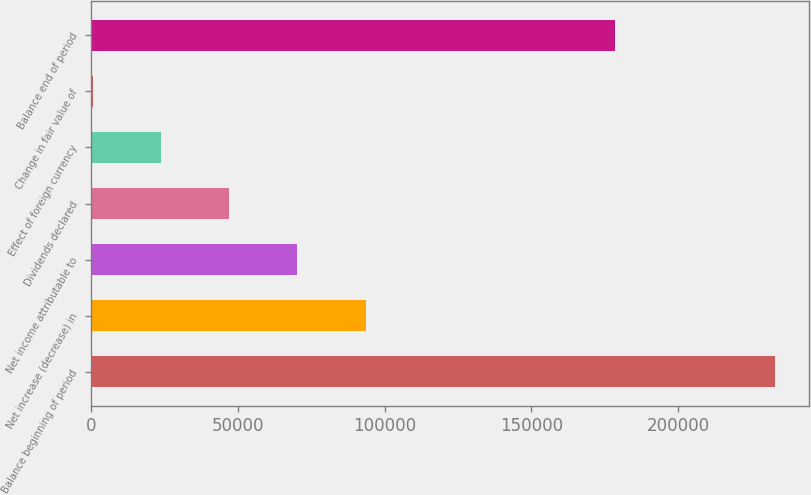Convert chart to OTSL. <chart><loc_0><loc_0><loc_500><loc_500><bar_chart><fcel>Balance beginning of period<fcel>Net increase (decrease) in<fcel>Net income attributable to<fcel>Dividends declared<fcel>Effect of foreign currency<fcel>Change in fair value of<fcel>Balance end of period<nl><fcel>233035<fcel>93562.6<fcel>70317.2<fcel>47071.8<fcel>23826.4<fcel>581<fcel>178570<nl></chart> 